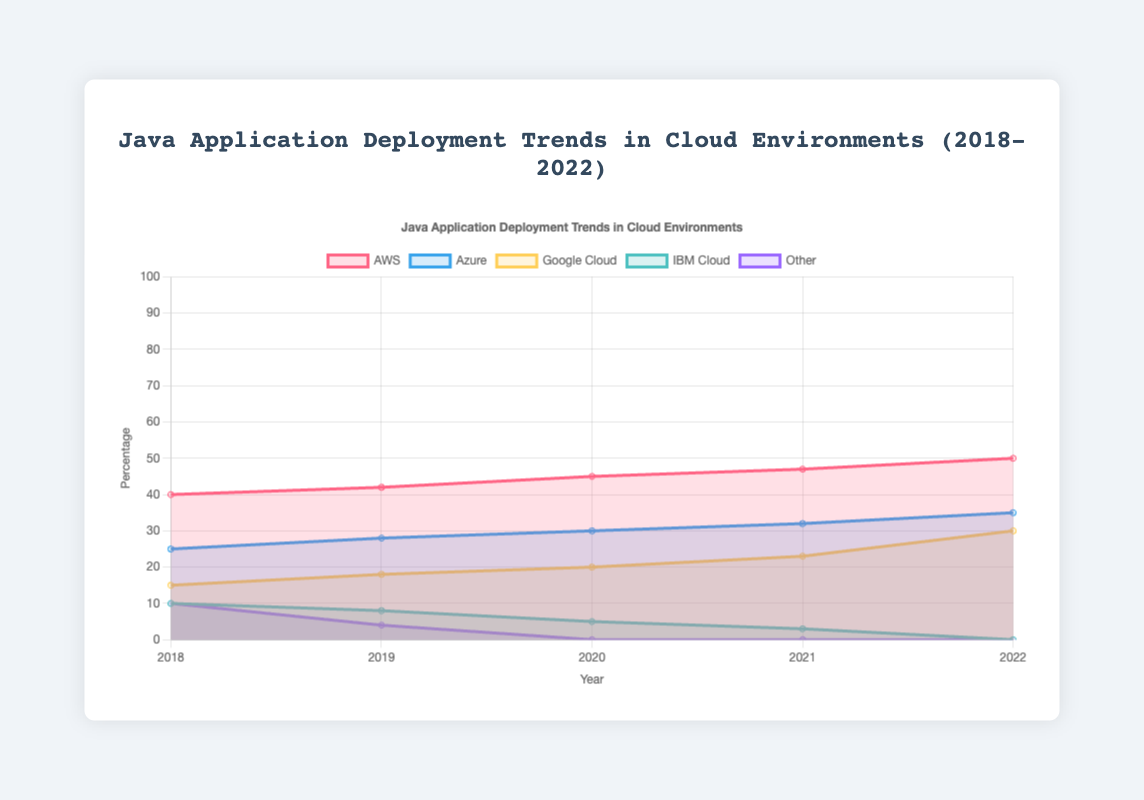What is the cloud environment with the highest percentage of Java application deployments in 2022? The figure shows the deployment trends for each cloud provider, and for 2022, AWS has the highest percentage at 50%.
Answer: AWS Which cloud environment saw the highest increase in Java application deployments from 2018 to 2022? To determine this, subtract the 2018 deployment percentage from the 2022 percentage for each cloud provider. AWS: 50-40=10, Azure: 35-25=10, Google Cloud: 30-15=15, IBM Cloud: 0-10=-10, Other: 0-10=-10. Google Cloud has the highest increase of 15%.
Answer: Google Cloud What trend did the "Other" category show over the period from 2018 to 2022? The trend in the "Other" category shows a decline from 10% in 2018 to 0% in 2020 and stays at 0% through 2022.
Answer: Decline to 0% In which year did Azure surpass 30% in Java application deployments? By checking each year's Azure percentage, Azure surpassed 30% in 2020 when it reached 30% and then increased in subsequent years.
Answer: 2020 How did IBM Cloud's Java application deployment percentage change from 2018 to 2022? IBM Cloud's deployment percentage decreased from 10% in 2018 to 0% in 2022. Calculating the difference: 0% - 10% = -10%.
Answer: Decreased by 10% If you sum the Java application deployment percentages for Google Cloud across all years, what is the total? Adding the percentages for each year: 15 + 18 + 20 + 23 + 30 = 106.
Answer: 106 Which cloud provider had the least percentage of Java application deployments in 2021, and what was this percentage? Looking at the 2021 data, IBM Cloud had the least percentage at 3%.
Answer: IBM Cloud, 3% How does the trend of Azure compare to that of AWS from 2018 to 2022? Both AWS and Azure show an upward trend from 2018 to 2022. AWS increased from 40% to 50%, and Azure increased from 25% to 35%, showing consistent growth.
Answer: Upward trend for both By how much did the Google Cloud percentage change from 2019 to 2020? To find the change, subtract the 2019 percentage from the 2020 percentage for Google Cloud: 20% - 18% = 2%.
Answer: Increased by 2% 